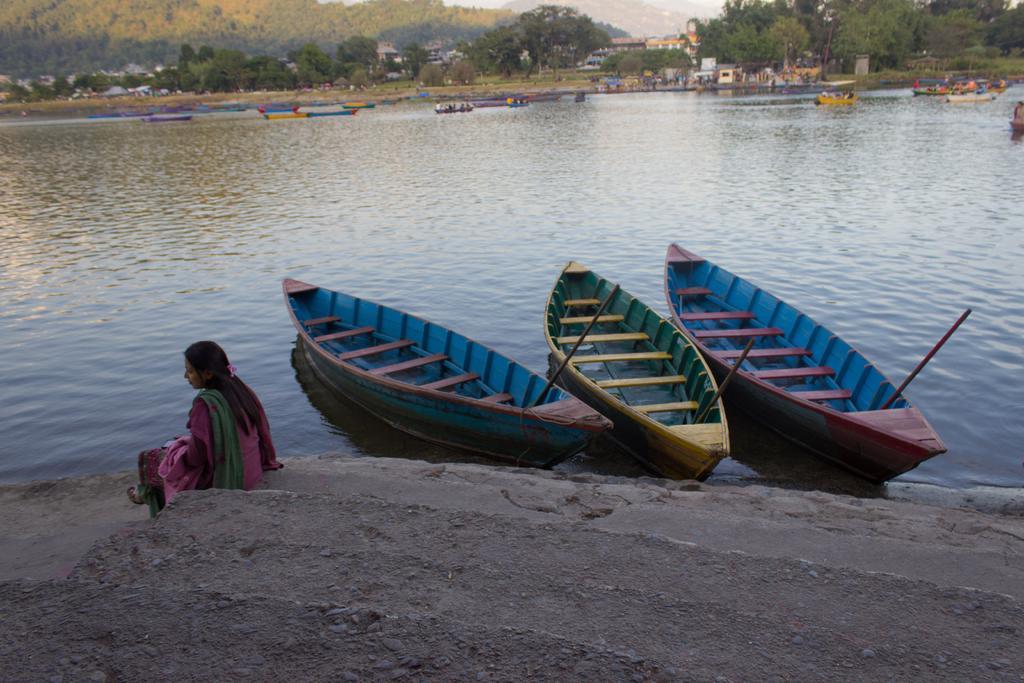Can you describe this image briefly? In this picture we can see a woman sitting on steps, boats on the water, buildings, trees, some objects and in the background we can see mountains. 